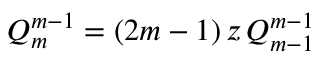Convert formula to latex. <formula><loc_0><loc_0><loc_500><loc_500>Q _ { m } ^ { m - 1 } = ( 2 m - 1 ) \, z \, Q _ { m - 1 } ^ { m - 1 }</formula> 